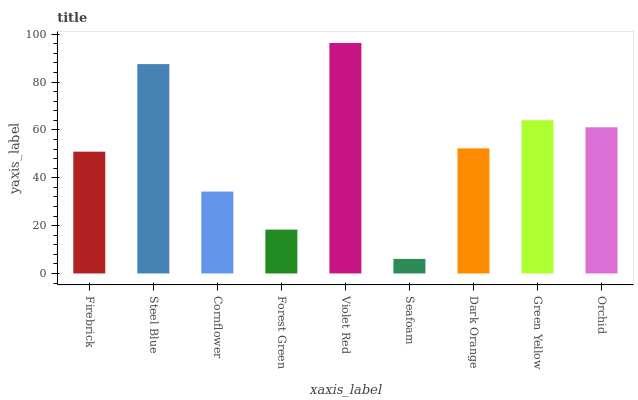Is Seafoam the minimum?
Answer yes or no. Yes. Is Violet Red the maximum?
Answer yes or no. Yes. Is Steel Blue the minimum?
Answer yes or no. No. Is Steel Blue the maximum?
Answer yes or no. No. Is Steel Blue greater than Firebrick?
Answer yes or no. Yes. Is Firebrick less than Steel Blue?
Answer yes or no. Yes. Is Firebrick greater than Steel Blue?
Answer yes or no. No. Is Steel Blue less than Firebrick?
Answer yes or no. No. Is Dark Orange the high median?
Answer yes or no. Yes. Is Dark Orange the low median?
Answer yes or no. Yes. Is Orchid the high median?
Answer yes or no. No. Is Steel Blue the low median?
Answer yes or no. No. 